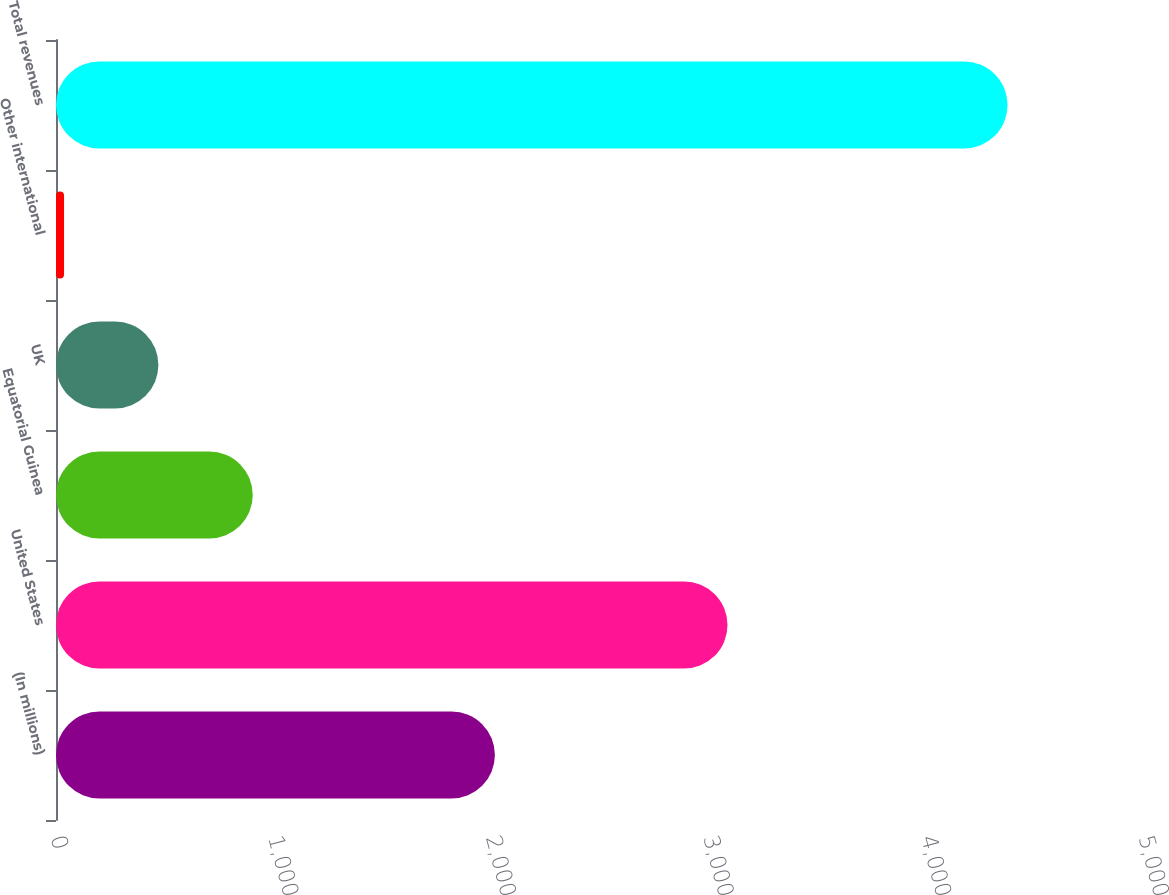Convert chart to OTSL. <chart><loc_0><loc_0><loc_500><loc_500><bar_chart><fcel>(In millions)<fcel>United States<fcel>Equatorial Guinea<fcel>UK<fcel>Other international<fcel>Total revenues<nl><fcel>2017<fcel>3086<fcel>904.2<fcel>470.6<fcel>37<fcel>4373<nl></chart> 